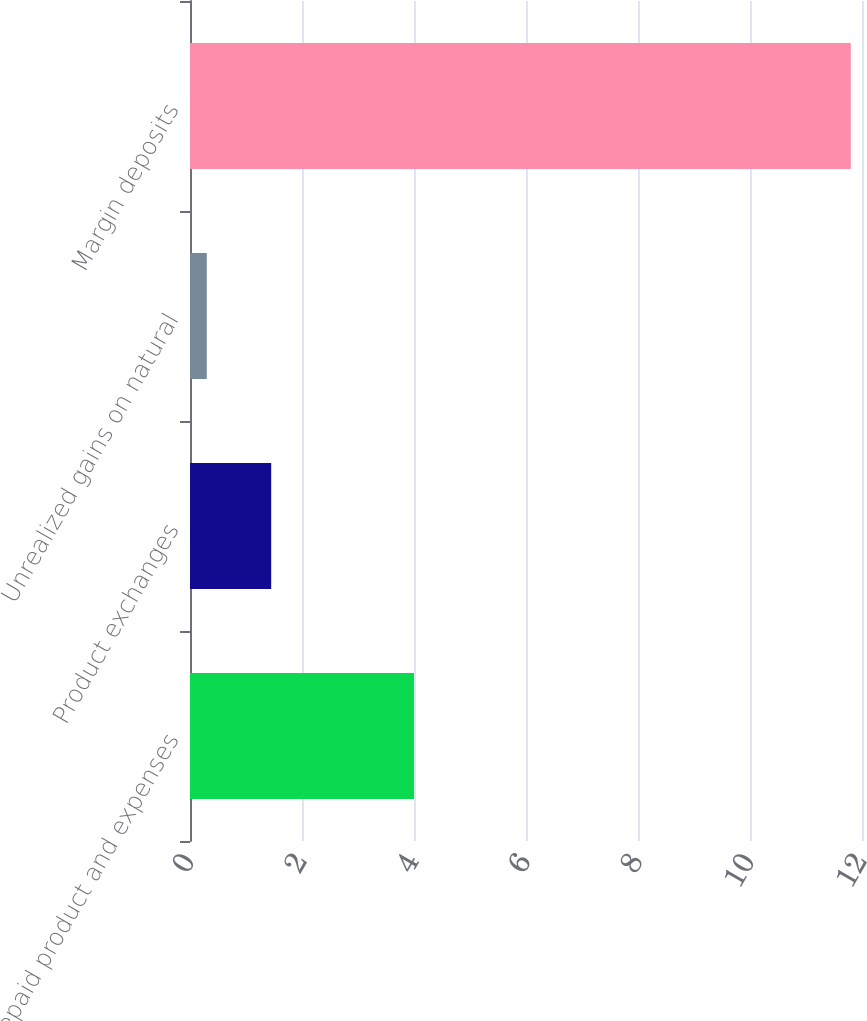Convert chart to OTSL. <chart><loc_0><loc_0><loc_500><loc_500><bar_chart><fcel>Prepaid product and expenses<fcel>Product exchanges<fcel>Unrealized gains on natural<fcel>Margin deposits<nl><fcel>4<fcel>1.45<fcel>0.3<fcel>11.8<nl></chart> 